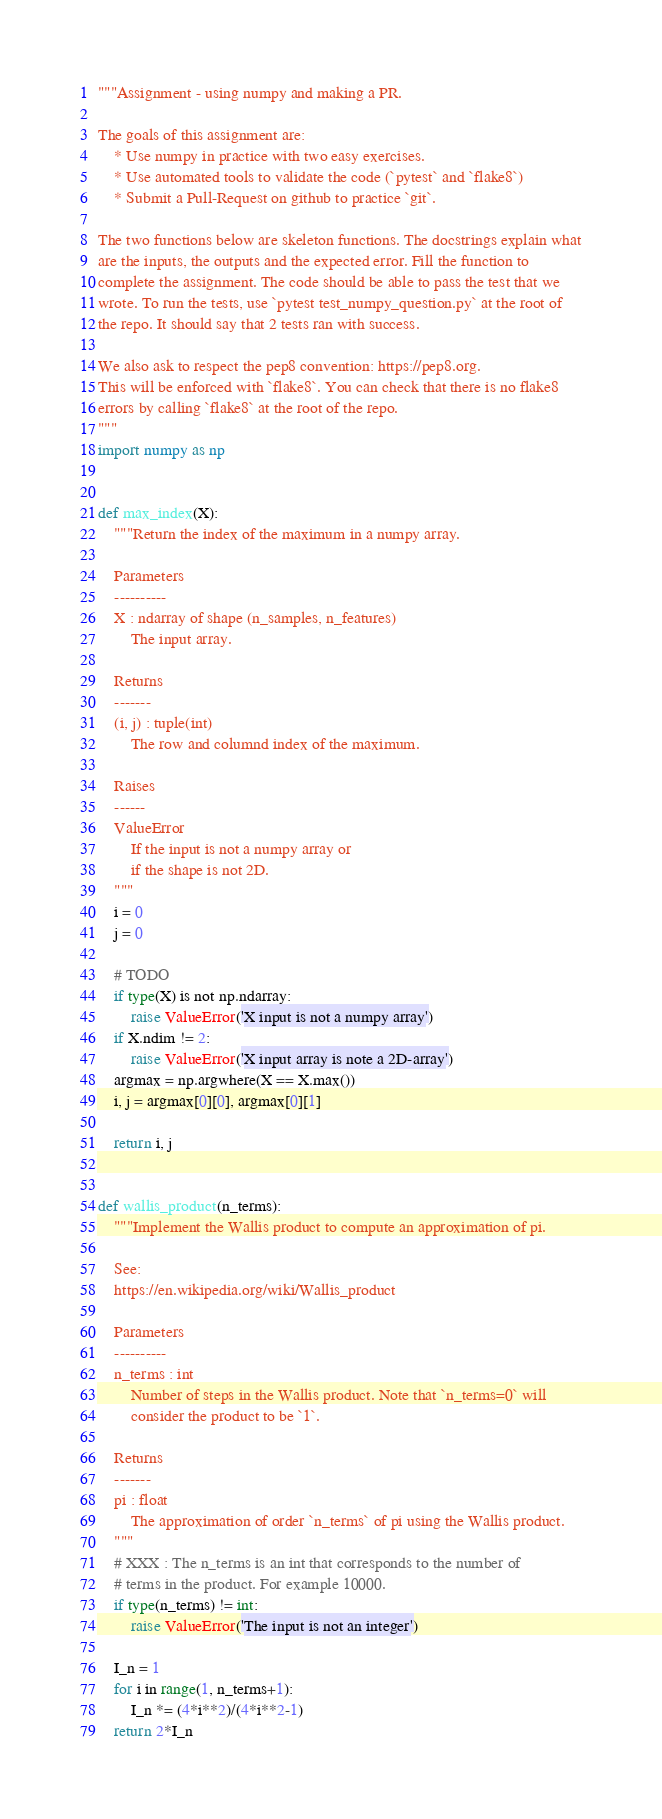<code> <loc_0><loc_0><loc_500><loc_500><_Python_>"""Assignment - using numpy and making a PR.

The goals of this assignment are:
    * Use numpy in practice with two easy exercises.
    * Use automated tools to validate the code (`pytest` and `flake8`)
    * Submit a Pull-Request on github to practice `git`.

The two functions below are skeleton functions. The docstrings explain what
are the inputs, the outputs and the expected error. Fill the function to
complete the assignment. The code should be able to pass the test that we
wrote. To run the tests, use `pytest test_numpy_question.py` at the root of
the repo. It should say that 2 tests ran with success.

We also ask to respect the pep8 convention: https://pep8.org.
This will be enforced with `flake8`. You can check that there is no flake8
errors by calling `flake8` at the root of the repo.
"""
import numpy as np


def max_index(X):
    """Return the index of the maximum in a numpy array.

    Parameters
    ----------
    X : ndarray of shape (n_samples, n_features)
        The input array.

    Returns
    -------
    (i, j) : tuple(int)
        The row and columnd index of the maximum.

    Raises
    ------
    ValueError
        If the input is not a numpy array or
        if the shape is not 2D.
    """
    i = 0
    j = 0

    # TODO
    if type(X) is not np.ndarray:
        raise ValueError('X input is not a numpy array')
    if X.ndim != 2:
        raise ValueError('X input array is note a 2D-array')
    argmax = np.argwhere(X == X.max())
    i, j = argmax[0][0], argmax[0][1]

    return i, j


def wallis_product(n_terms):
    """Implement the Wallis product to compute an approximation of pi.

    See:
    https://en.wikipedia.org/wiki/Wallis_product

    Parameters
    ----------
    n_terms : int
        Number of steps in the Wallis product. Note that `n_terms=0` will
        consider the product to be `1`.

    Returns
    -------
    pi : float
        The approximation of order `n_terms` of pi using the Wallis product.
    """
    # XXX : The n_terms is an int that corresponds to the number of
    # terms in the product. For example 10000.
    if type(n_terms) != int:
        raise ValueError('The input is not an integer')

    I_n = 1
    for i in range(1, n_terms+1):
        I_n *= (4*i**2)/(4*i**2-1)
    return 2*I_n
</code> 